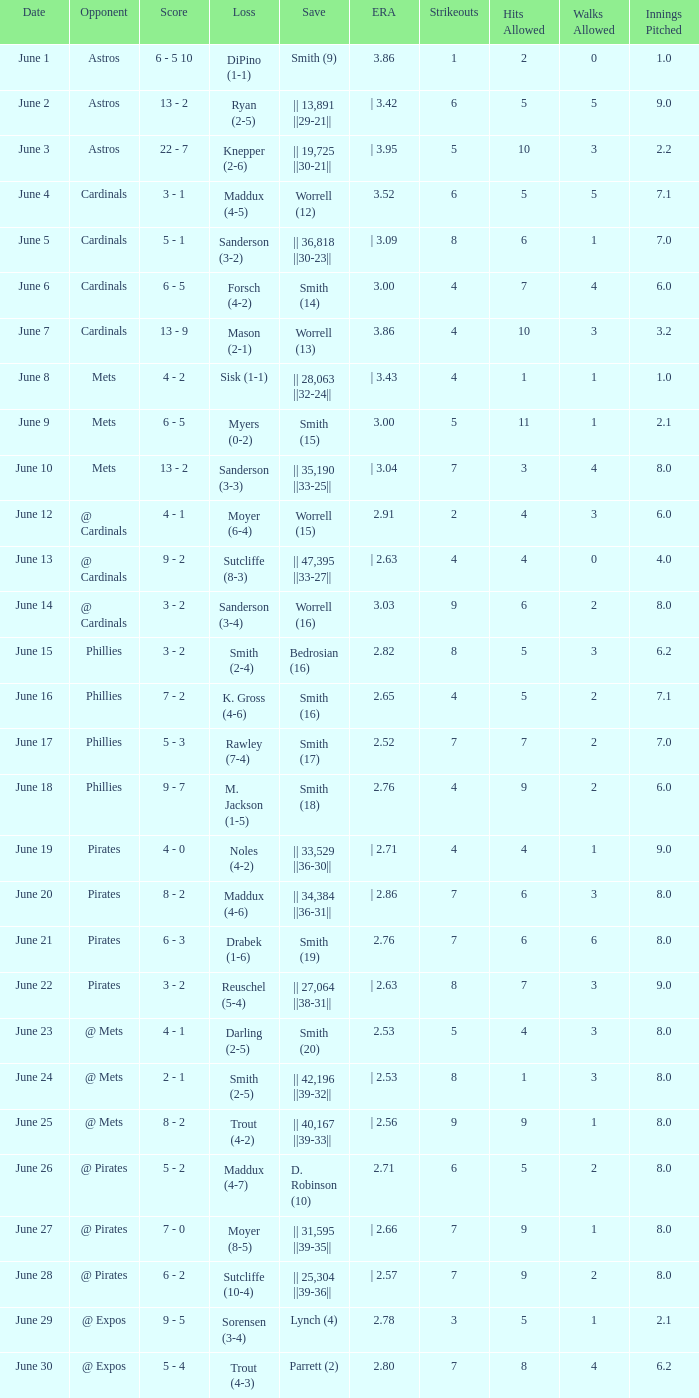What is the loss for the game against @ expos, with a save of parrett (2)? Trout (4-3). 